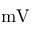<formula> <loc_0><loc_0><loc_500><loc_500>m V</formula> 